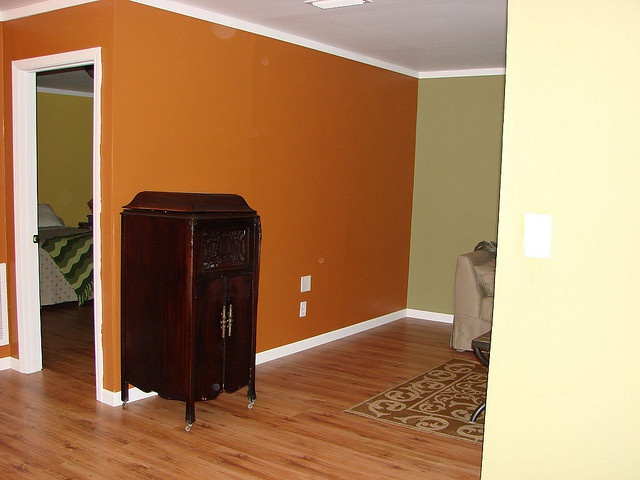Describe the objects in this image and their specific colors. I can see bed in gray, black, and darkgreen tones and couch in gray tones in this image. 